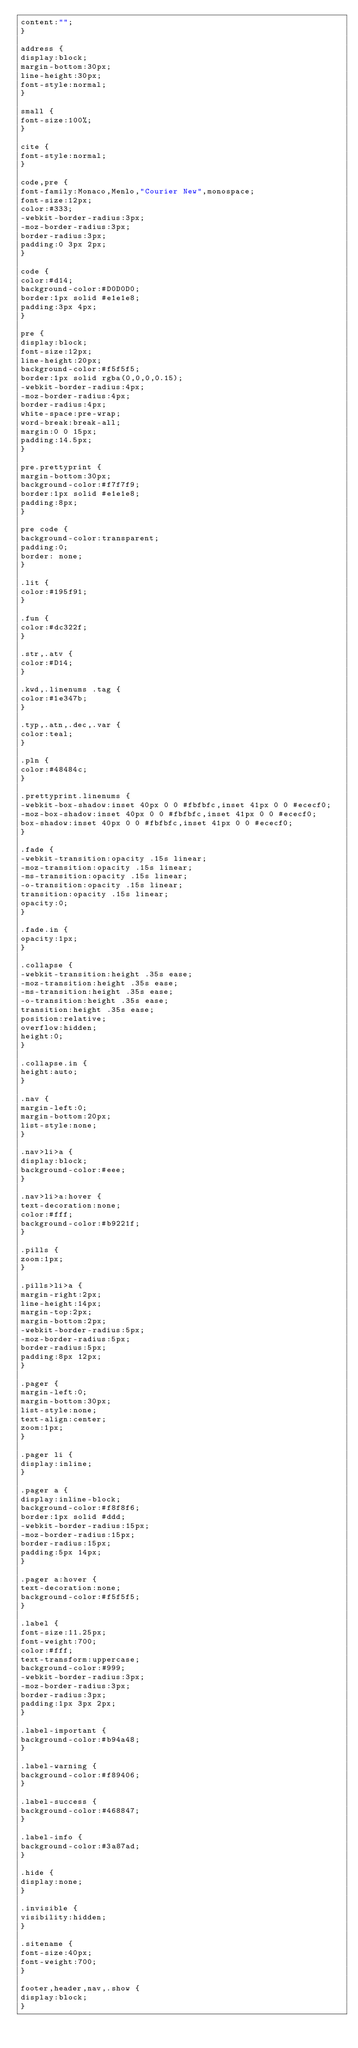Convert code to text. <code><loc_0><loc_0><loc_500><loc_500><_CSS_>content:"";
}

address {
display:block;
margin-bottom:30px;
line-height:30px;
font-style:normal;
}

small {
font-size:100%;
}

cite {
font-style:normal;
}

code,pre {
font-family:Monaco,Menlo,"Courier New",monospace;
font-size:12px;
color:#333;
-webkit-border-radius:3px;
-moz-border-radius:3px;
border-radius:3px;
padding:0 3px 2px;
}

code {
color:#d14;
background-color:#D0D0D0;
border:1px solid #e1e1e8;
padding:3px 4px;
}

pre {
display:block;
font-size:12px;
line-height:20px;
background-color:#f5f5f5;
border:1px solid rgba(0,0,0,0.15);
-webkit-border-radius:4px;
-moz-border-radius:4px;
border-radius:4px;
white-space:pre-wrap;
word-break:break-all;
margin:0 0 15px;
padding:14.5px;
}

pre.prettyprint {
margin-bottom:30px;
background-color:#f7f7f9;
border:1px solid #e1e1e8;
padding:8px;
}

pre code {
background-color:transparent;
padding:0;
border: none;
}

.lit {
color:#195f91;
}

.fun {
color:#dc322f;
}

.str,.atv {
color:#D14;
}

.kwd,.linenums .tag {
color:#1e347b;
}

.typ,.atn,.dec,.var {
color:teal;
}

.pln {
color:#48484c;
}

.prettyprint.linenums {
-webkit-box-shadow:inset 40px 0 0 #fbfbfc,inset 41px 0 0 #ececf0;
-moz-box-shadow:inset 40px 0 0 #fbfbfc,inset 41px 0 0 #ececf0;
box-shadow:inset 40px 0 0 #fbfbfc,inset 41px 0 0 #ececf0;
}

.fade {
-webkit-transition:opacity .15s linear;
-moz-transition:opacity .15s linear;
-ms-transition:opacity .15s linear;
-o-transition:opacity .15s linear;
transition:opacity .15s linear;
opacity:0;
}

.fade.in {
opacity:1px;
}

.collapse {
-webkit-transition:height .35s ease;
-moz-transition:height .35s ease;
-ms-transition:height .35s ease;
-o-transition:height .35s ease;
transition:height .35s ease;
position:relative;
overflow:hidden;
height:0;
}

.collapse.in {
height:auto;
}

.nav {
margin-left:0;
margin-bottom:20px;
list-style:none;
}

.nav>li>a {
display:block;
background-color:#eee;
}

.nav>li>a:hover {
text-decoration:none;
color:#fff;
background-color:#b9221f;
}

.pills {
zoom:1px;
}

.pills>li>a {
margin-right:2px;
line-height:14px;
margin-top:2px;
margin-bottom:2px;
-webkit-border-radius:5px;
-moz-border-radius:5px;
border-radius:5px;
padding:8px 12px;
}

.pager {
margin-left:0;
margin-bottom:30px;
list-style:none;
text-align:center;
zoom:1px;
}

.pager li {
display:inline;
}

.pager a {
display:inline-block;
background-color:#f8f8f6;
border:1px solid #ddd;
-webkit-border-radius:15px;
-moz-border-radius:15px;
border-radius:15px;
padding:5px 14px;
}

.pager a:hover {
text-decoration:none;
background-color:#f5f5f5;
}

.label {
font-size:11.25px;
font-weight:700;
color:#fff;
text-transform:uppercase;
background-color:#999;
-webkit-border-radius:3px;
-moz-border-radius:3px;
border-radius:3px;
padding:1px 3px 2px;
}

.label-important {
background-color:#b94a48;
}

.label-warning {
background-color:#f89406;
}

.label-success {
background-color:#468847;
}

.label-info {
background-color:#3a87ad;
}

.hide {
display:none;
}

.invisible {
visibility:hidden;
}

.sitename {
font-size:40px;
font-weight:700;
}

footer,header,nav,.show {
display:block;
}
</code> 